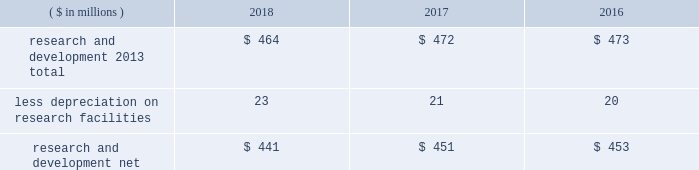52 2018 ppg annual report and 10-k 1 .
Summary of significant accounting policies principles of consolidation the accompanying consolidated financial statements include the accounts of ppg industries , inc .
( 201cppg 201d or the 201ccompany 201d ) and all subsidiaries , both u.s .
And non-u.s. , that it controls .
Ppg owns more than 50% ( 50 % ) of the voting stock of most of the subsidiaries that it controls .
For those consolidated subsidiaries in which the company 2019s ownership is less than 100% ( 100 % ) , the outside shareholders 2019 interests are shown as noncontrolling interests .
Investments in companies in which ppg owns 20% ( 20 % ) to 50% ( 50 % ) of the voting stock and has the ability to exercise significant influence over operating and financial policies of the investee are accounted for using the equity method of accounting .
As a result , ppg 2019s share of income or losses from such equity affiliates is included in the consolidated statement of income and ppg 2019s share of these companies 2019 shareholders 2019 equity is included in investments on the consolidated balance sheet .
Transactions between ppg and its subsidiaries are eliminated in consolidation .
Use of estimates in the preparation of financial statements the preparation of financial statements in conformity with u.s .
Generally accepted accounting principles requires management to make estimates and assumptions that affect the reported amounts of assets and liabilities and the disclosure of contingent assets and liabilities at the date of the financial statements , as well as the reported amounts of income and expenses during the reporting period .
Such estimates also include the fair value of assets acquired and liabilities assumed resulting from the allocation of the purchase price related to business combinations consummated .
Actual outcomes could differ from those estimates .
Revenue recognition revenue is recognized as performance obligations with the customer are satisfied , at an amount that is determined to be collectible .
For the sale of products , this generally occurs at the point in time when control of the company 2019s products transfers to the customer based on the agreed upon shipping terms .
Shipping and handling costs amounts billed to customers for shipping and handling are reported in net sales in the consolidated statement of income .
Shipping and handling costs incurred by the company for the delivery of goods to customers are included in cost of sales , exclusive of depreciation and amortization in the consolidated statement of income .
Selling , general and administrative costs amounts presented in selling , general and administrative in the consolidated statement of income are comprised of selling , customer service , distribution and advertising costs , as well as the costs of providing corporate-wide functional support in such areas as finance , law , human resources and planning .
Distribution costs pertain to the movement and storage of finished goods inventory at company-owned and leased warehouses and other distribution facilities .
Advertising costs advertising costs are expensed as incurred and totaled $ 280 million , $ 313 million and $ 322 million in 2018 , 2017 and 2016 , respectively .
Research and development research and development costs , which consist primarily of employee related costs , are charged to expense as incurred. .
Legal costs legal costs , primarily include costs associated with acquisition and divestiture transactions , general litigation , environmental regulation compliance , patent and trademark protection and other general corporate purposes , are charged to expense as incurred .
Income taxes income taxes are accounted for under the asset and liability method .
Deferred tax assets and liabilities are recognized for the future tax consequences attributable to operating losses and tax credit carryforwards as well as differences between the financial statement carrying amounts of existing assets and liabilities and their respective tax bases .
The effect on deferred notes to the consolidated financial statements .
Were 2018 advertising costs greater than r&d expenses? 
Computations: (280 > 464)
Answer: no. 